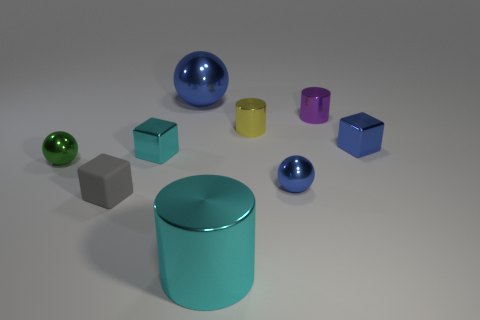Subtract all large shiny balls. How many balls are left? 2 Add 4 tiny cyan objects. How many tiny cyan objects are left? 5 Add 5 large brown metallic balls. How many large brown metallic balls exist? 5 Add 1 small purple metallic objects. How many objects exist? 10 Subtract all blue balls. How many balls are left? 1 Subtract 0 purple spheres. How many objects are left? 9 Subtract all cubes. How many objects are left? 6 Subtract 1 blocks. How many blocks are left? 2 Subtract all purple cylinders. Subtract all brown balls. How many cylinders are left? 2 Subtract all cyan cylinders. How many blue balls are left? 2 